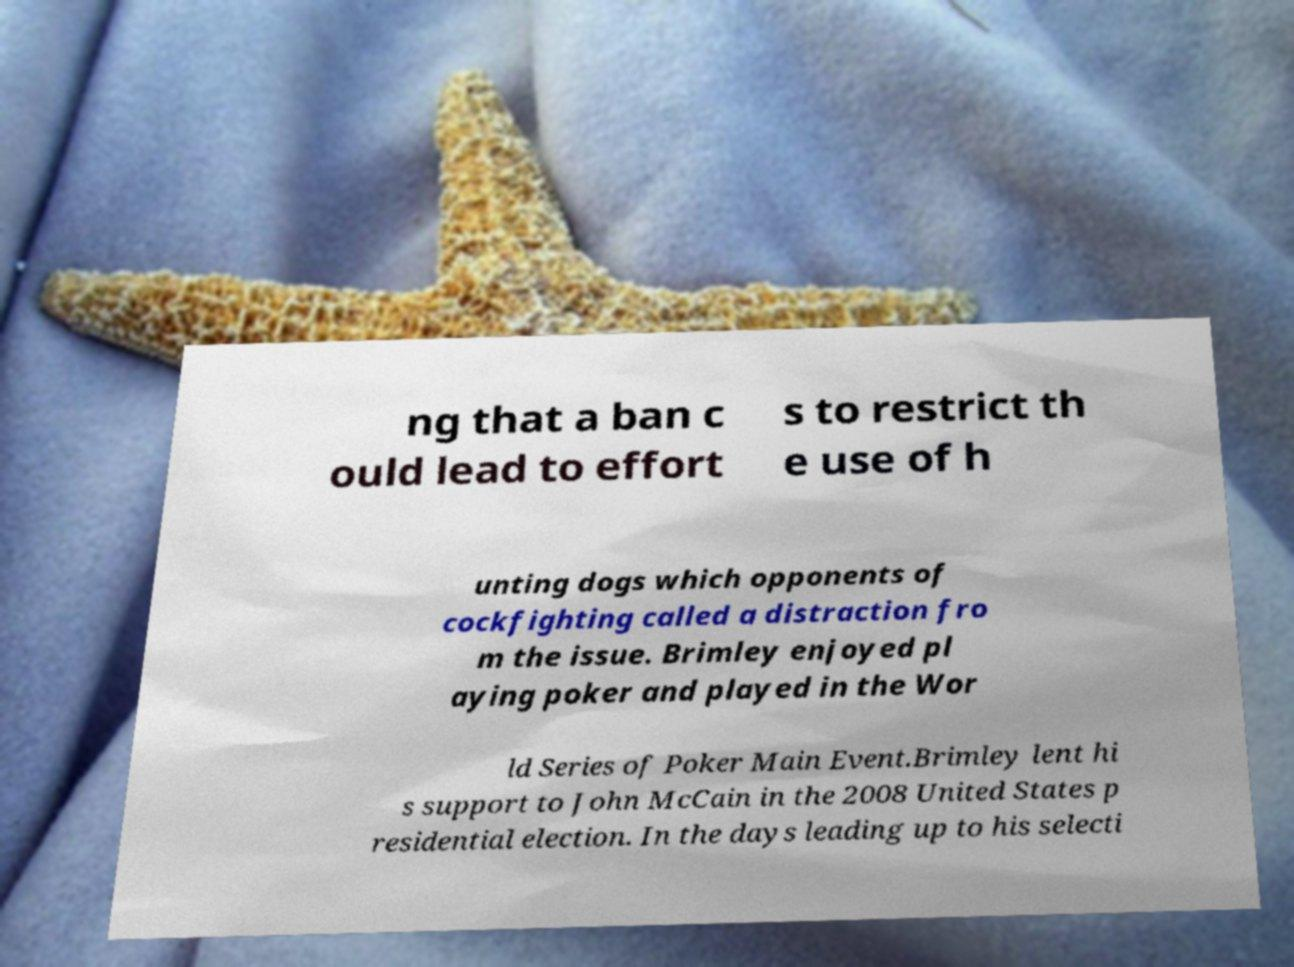Can you read and provide the text displayed in the image?This photo seems to have some interesting text. Can you extract and type it out for me? ng that a ban c ould lead to effort s to restrict th e use of h unting dogs which opponents of cockfighting called a distraction fro m the issue. Brimley enjoyed pl aying poker and played in the Wor ld Series of Poker Main Event.Brimley lent hi s support to John McCain in the 2008 United States p residential election. In the days leading up to his selecti 